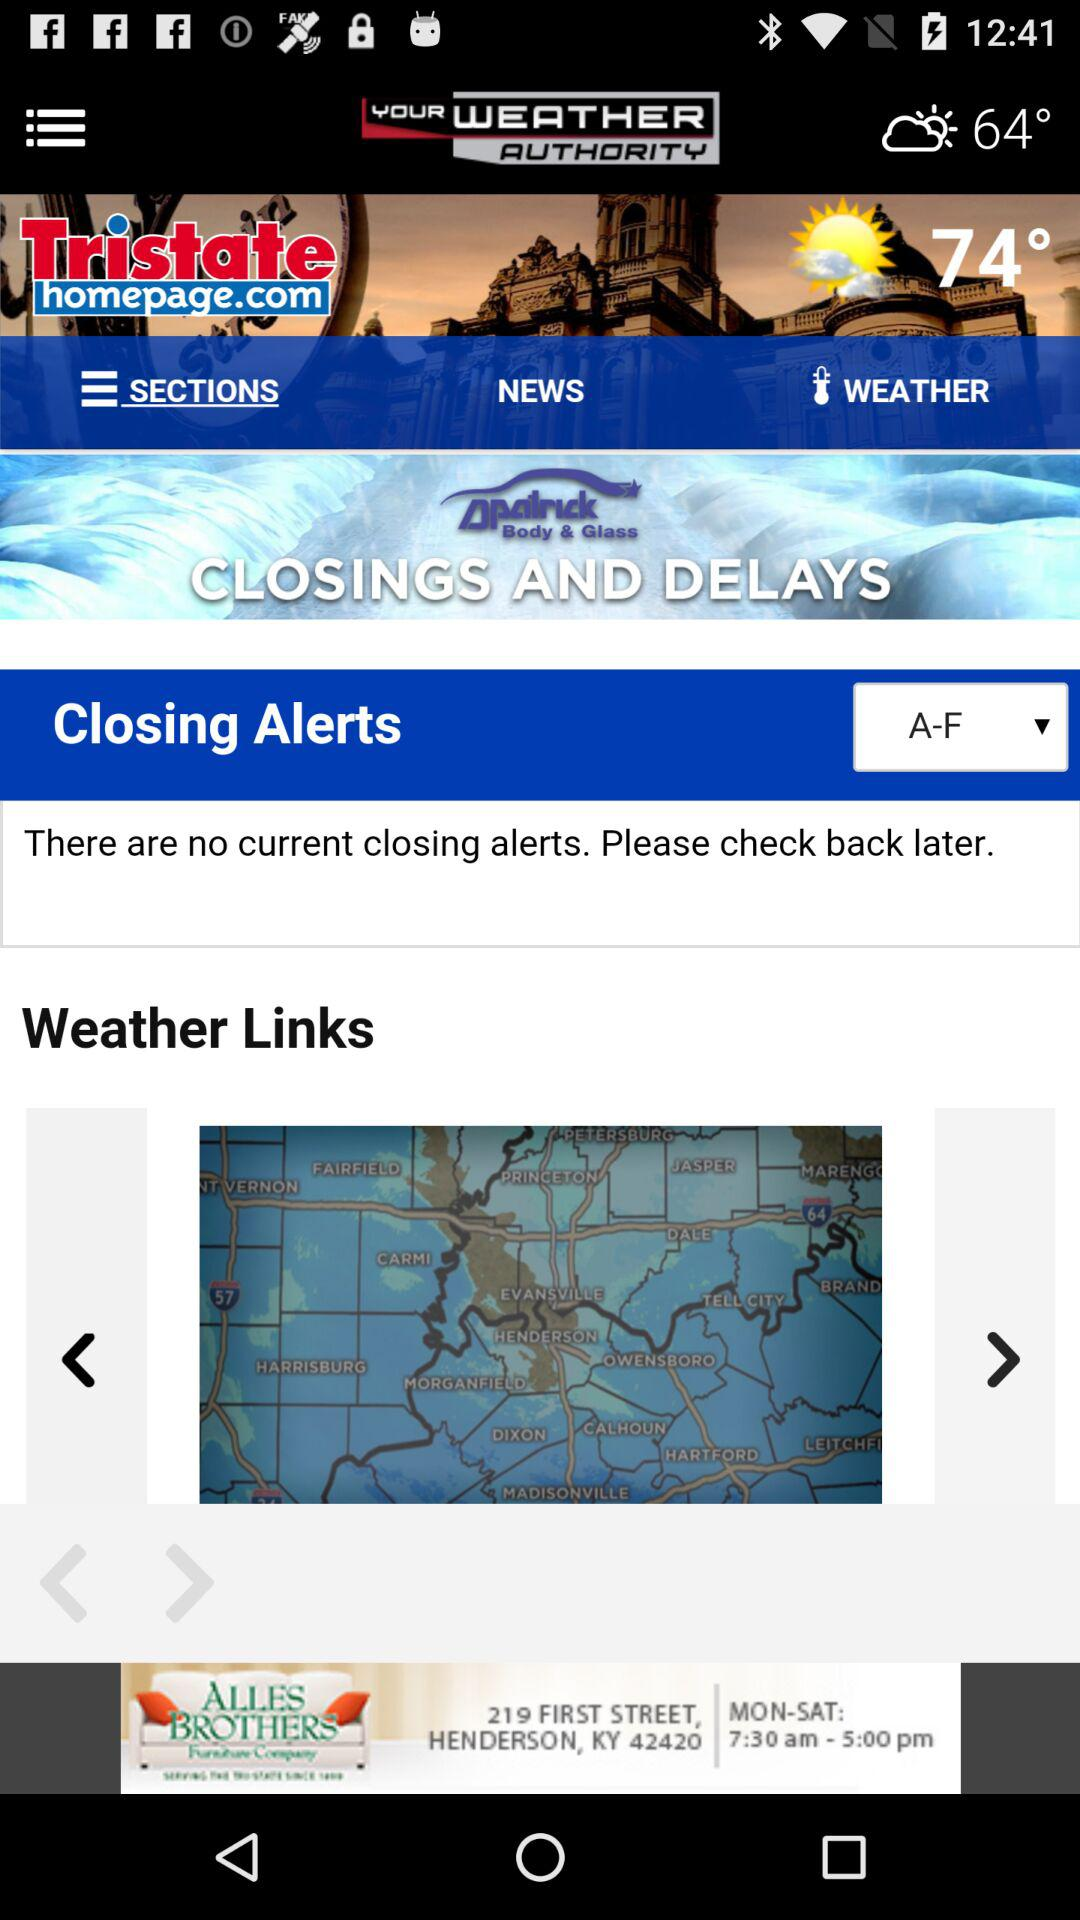How many more degrees is the temperature in the castle than the penguin?
Answer the question using a single word or phrase. 10° 